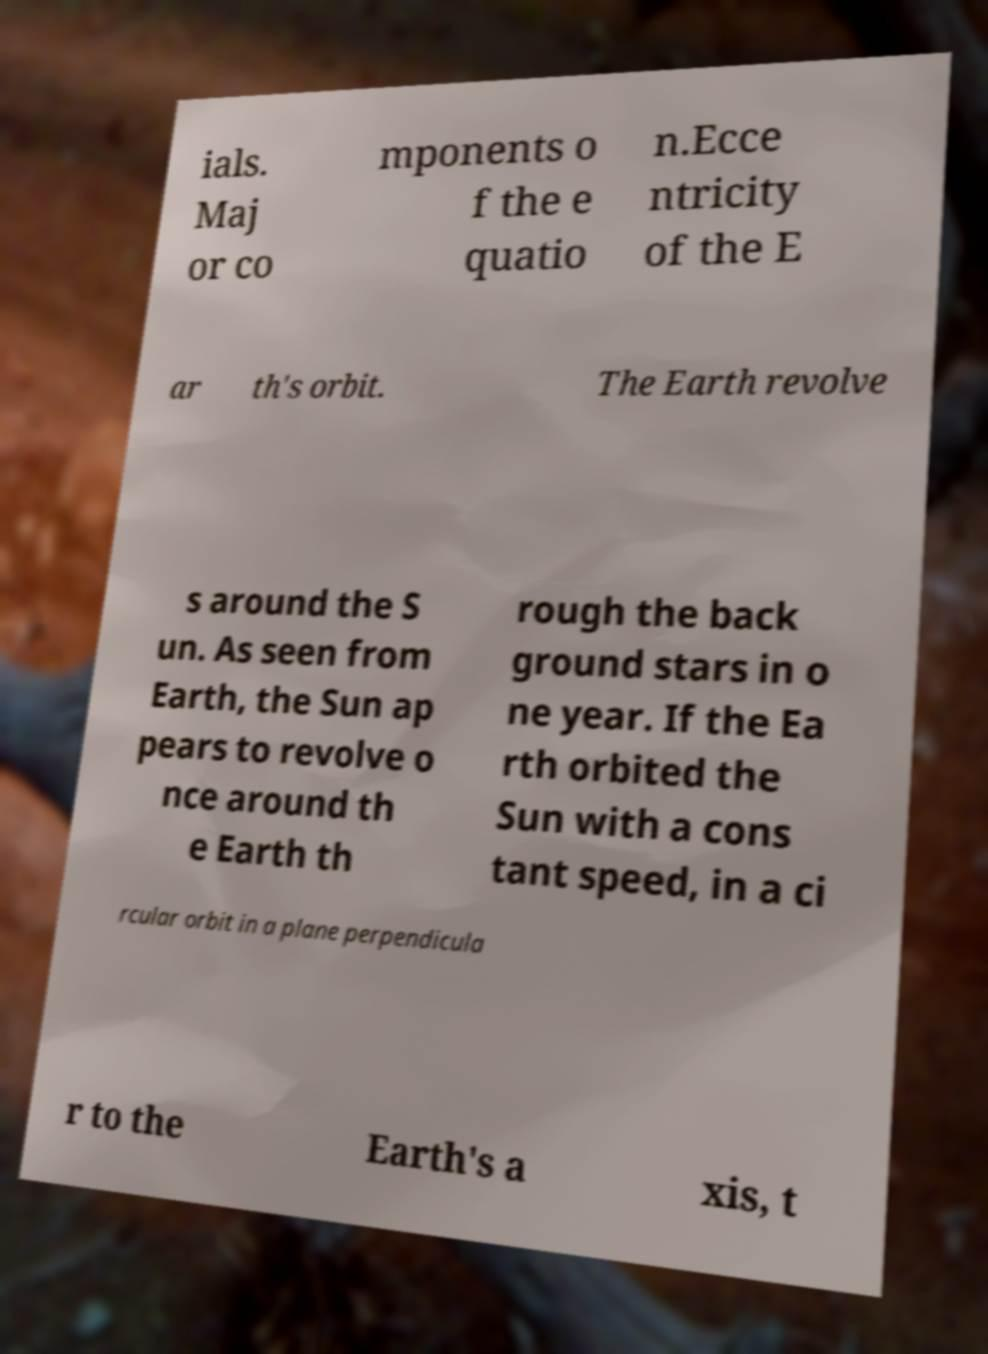Please read and relay the text visible in this image. What does it say? ials. Maj or co mponents o f the e quatio n.Ecce ntricity of the E ar th's orbit. The Earth revolve s around the S un. As seen from Earth, the Sun ap pears to revolve o nce around th e Earth th rough the back ground stars in o ne year. If the Ea rth orbited the Sun with a cons tant speed, in a ci rcular orbit in a plane perpendicula r to the Earth's a xis, t 